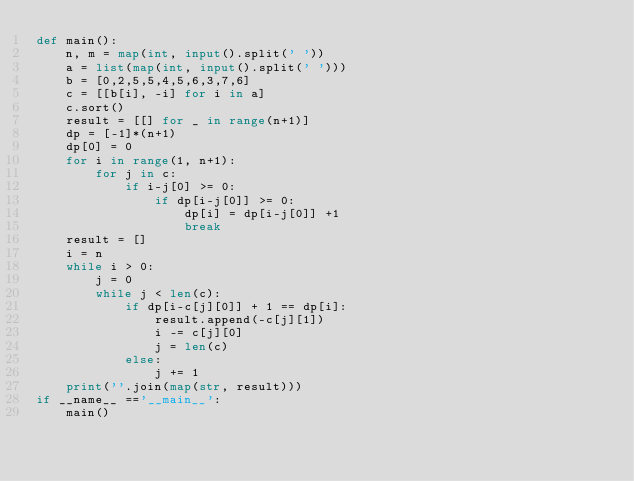Convert code to text. <code><loc_0><loc_0><loc_500><loc_500><_Python_>def main():
    n, m = map(int, input().split(' '))
    a = list(map(int, input().split(' ')))
    b = [0,2,5,5,4,5,6,3,7,6]
    c = [[b[i], -i] for i in a]
    c.sort()
    result = [[] for _ in range(n+1)]
    dp = [-1]*(n+1)
    dp[0] = 0
    for i in range(1, n+1):
        for j in c:
            if i-j[0] >= 0:
                if dp[i-j[0]] >= 0:
                    dp[i] = dp[i-j[0]] +1
                    break
    result = []
    i = n
    while i > 0:
        j = 0
        while j < len(c):
            if dp[i-c[j][0]] + 1 == dp[i]:
                result.append(-c[j][1])
                i -= c[j][0]
                j = len(c)
            else:
                j += 1            
    print(''.join(map(str, result)))
if __name__ =='__main__':
    main()</code> 